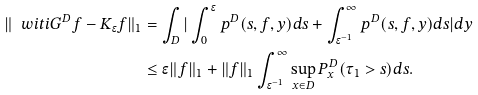<formula> <loc_0><loc_0><loc_500><loc_500>\| \ w i t i { G ^ { D } } f - K _ { \epsilon } f \| _ { 1 } & = \int _ { D } | \int _ { 0 } ^ { \epsilon } p ^ { D } ( s , f , y ) d s + \int _ { \epsilon ^ { - 1 } } ^ { \infty } p ^ { D } ( s , f , y ) d s | d y \\ & \leq \epsilon \| f \| _ { 1 } + \| f \| _ { 1 } \int _ { \epsilon ^ { - 1 } } ^ { \infty } \sup _ { x \in D } P _ { x } ^ { D } ( \tau _ { 1 } > s ) d s .</formula> 